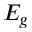<formula> <loc_0><loc_0><loc_500><loc_500>E _ { g }</formula> 